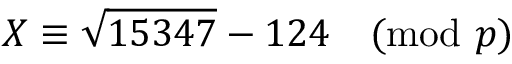<formula> <loc_0><loc_0><loc_500><loc_500>X \equiv \sqrt { 1 5 3 4 7 } - 1 2 4 { \pmod { p } }</formula> 